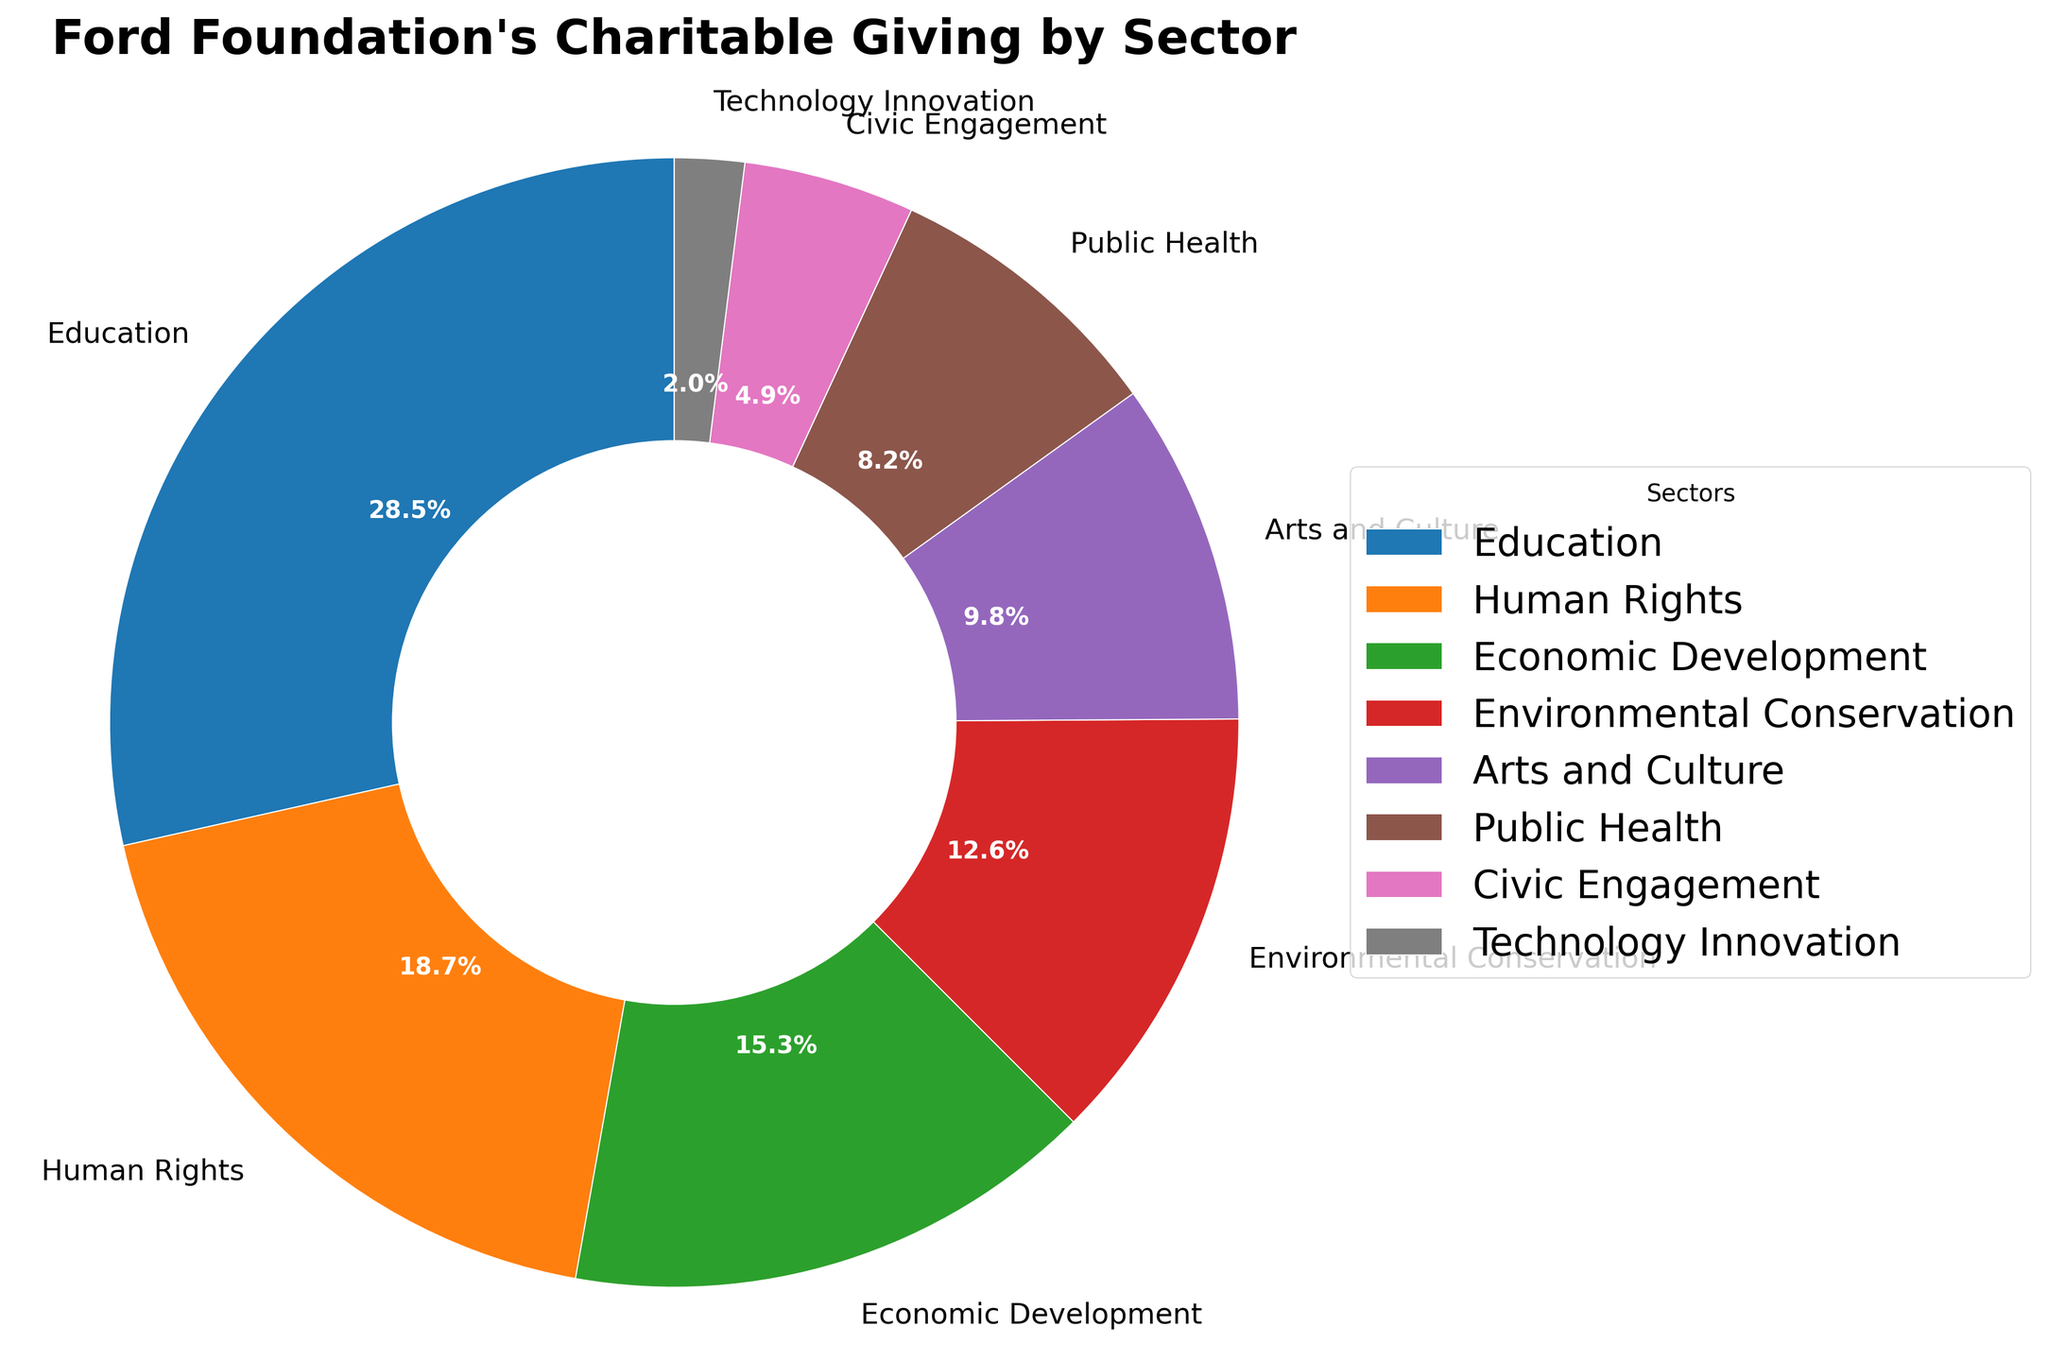What sector receives the highest percentage of charitable giving? The figure shows that the "Education" sector has the largest slice of the pie chart at 28.5%.
Answer: Education Which sector receives the least amount of charitable giving? The figure indicates that "Technology Innovation" has the smallest slice of the pie chart at 2.0%.
Answer: Technology Innovation What is the total percentage of charitable giving allocated to both "Education" and "Human Rights" sectors? The "Education" sector is 28.5% and the "Human Rights" sector is 18.7%. Summing them up gives us 28.5% + 18.7% = 47.2%.
Answer: 47.2% By how much percentage does "Economic Development" exceed "Civic Engagement"? The "Economic Development" sector is 15.3% and the "Civic Engagement" sector is 4.9%. Subtracting them gives us 15.3% - 4.9% = 10.4%.
Answer: 10.4% What are the combined percentages for the sectors involved in arts and public health? The "Arts and Culture" sector is allocated 9.8% and the "Public Health" sector 8.2%. Their combined percentage is 9.8% + 8.2% = 18.0%.
Answer: 18.0% How does the slice for "Environmental Conservation" compare visually to that of "Technology Innovation"? The slice for "Environmental Conservation" is much larger compared to that of "Technology Innovation", indicating a greater allocation percentage for Environmental Conservation (12.6%) compared to Technology Innovation (2.0%).
Answer: Environmental Conservation is larger Which sectors take up less than 10% of the total allocation? Sectors with less than 10% are "Technology Innovation" (2.0%), "Civic Engagement" (4.9%), "Public Health" (8.2%), and "Arts and Culture" (9.8%).
Answer: Technology Innovation, Civic Engagement, Public Health, Arts and Culture What is the average percentage for "Environmental Conservation", "Arts and Culture", and "Public Health"? Adding the percentages: 12.6% (Environmental Conservation), 9.8% (Arts and Culture), and 8.2% (Public Health) gives us 12.6 + 9.8 + 8.2 = 30.6. Dividing by 3, we get 30.6 / 3 = 10.2%.
Answer: 10.2% 